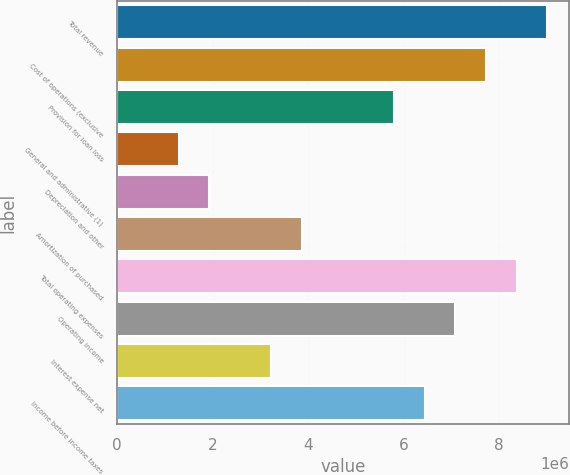Convert chart. <chart><loc_0><loc_0><loc_500><loc_500><bar_chart><fcel>Total revenue<fcel>Cost of operations (exclusive<fcel>Provision for loan loss<fcel>General and administrative (1)<fcel>Depreciation and other<fcel>Amortization of purchased<fcel>Total operating expenses<fcel>Operating income<fcel>Interest expense net<fcel>Income before income taxes<nl><fcel>9.01564e+06<fcel>7.72769e+06<fcel>5.79577e+06<fcel>1.28796e+06<fcel>1.93193e+06<fcel>3.86385e+06<fcel>8.37167e+06<fcel>7.08372e+06<fcel>3.21988e+06<fcel>6.43975e+06<nl></chart> 